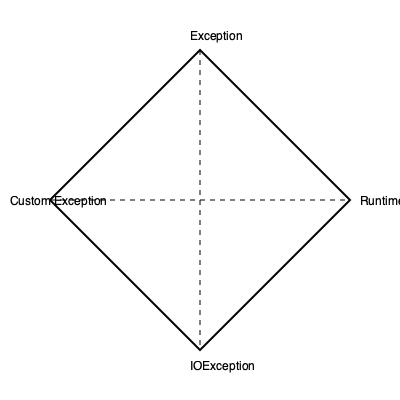If you fold this paper airplane along the dotted lines, which exception type will be directly opposite to "RuntimeException"? To solve this mental folding exercise, follow these steps:

1. Visualize folding the paper airplane along the vertical dotted line:
   - The left side (Custom Exception) will fold over to the right side.
   - The right side (RuntimeException) will remain visible.

2. Next, visualize folding the resulting shape along the horizontal dotted line:
   - The top part (Exception) will fold down.
   - The bottom part (IOException) will fold up.

3. After these two folds:
   - RuntimeException will be on the outside, visible surface.
   - The exception type directly opposite to it will be the one that was originally on the bottom left quadrant.

4. Identify the exception type in the bottom left quadrant:
   - This is "Custom Exception".

Therefore, after folding, "Custom Exception" will be directly opposite to "RuntimeException".
Answer: Custom Exception 